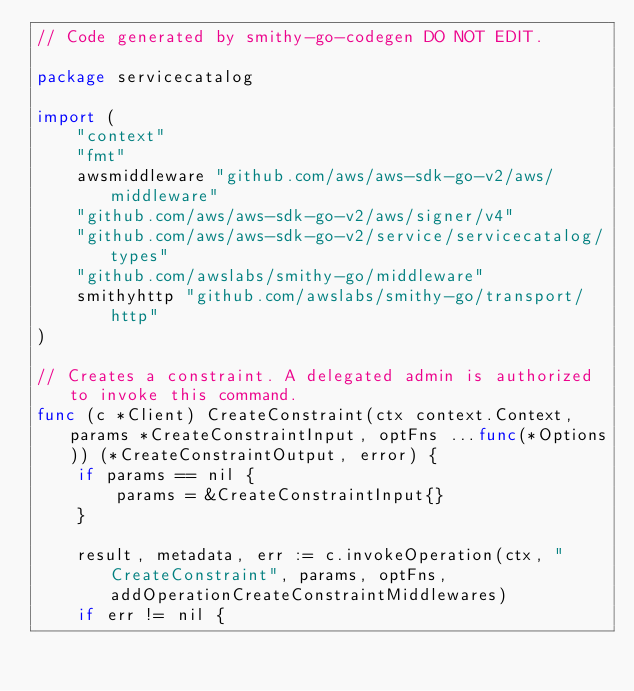<code> <loc_0><loc_0><loc_500><loc_500><_Go_>// Code generated by smithy-go-codegen DO NOT EDIT.

package servicecatalog

import (
	"context"
	"fmt"
	awsmiddleware "github.com/aws/aws-sdk-go-v2/aws/middleware"
	"github.com/aws/aws-sdk-go-v2/aws/signer/v4"
	"github.com/aws/aws-sdk-go-v2/service/servicecatalog/types"
	"github.com/awslabs/smithy-go/middleware"
	smithyhttp "github.com/awslabs/smithy-go/transport/http"
)

// Creates a constraint. A delegated admin is authorized to invoke this command.
func (c *Client) CreateConstraint(ctx context.Context, params *CreateConstraintInput, optFns ...func(*Options)) (*CreateConstraintOutput, error) {
	if params == nil {
		params = &CreateConstraintInput{}
	}

	result, metadata, err := c.invokeOperation(ctx, "CreateConstraint", params, optFns, addOperationCreateConstraintMiddlewares)
	if err != nil {</code> 